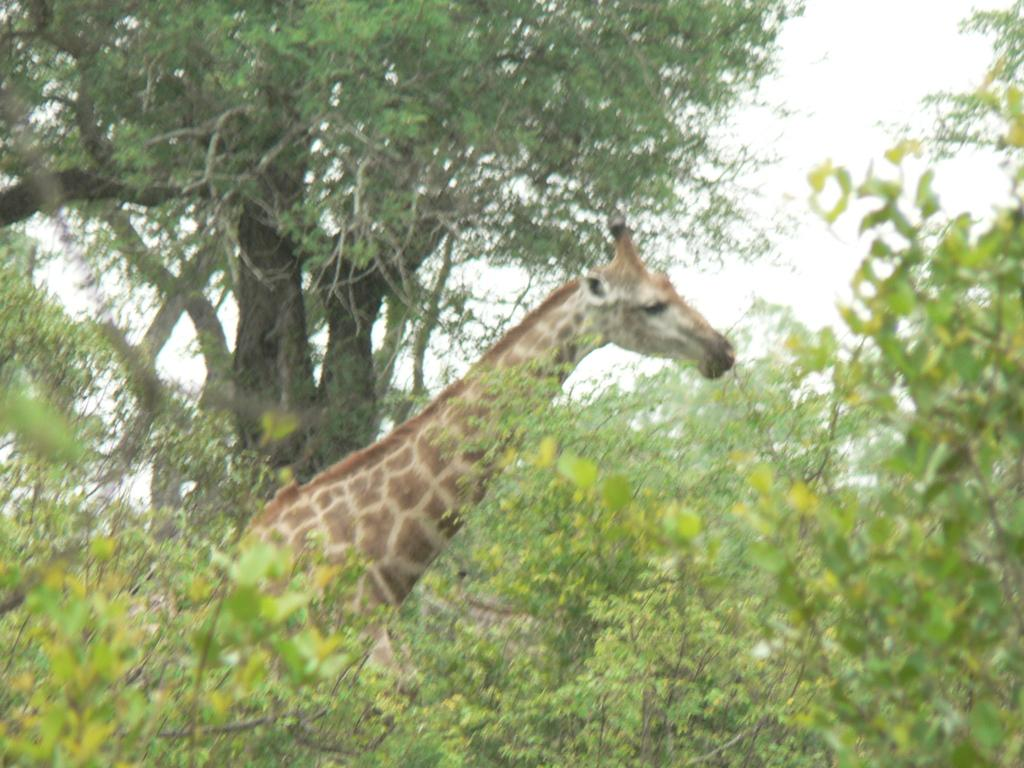What type of animal is in the image? There is a giraffe in the image. What other natural elements can be seen in the image? There are plants and trees in the image. What is visible in the background of the image? The sky is visible in the image. How many kittens are climbing the giraffe in the image? There are no kittens present in the image; it features a giraffe, plants, trees, and the sky. 